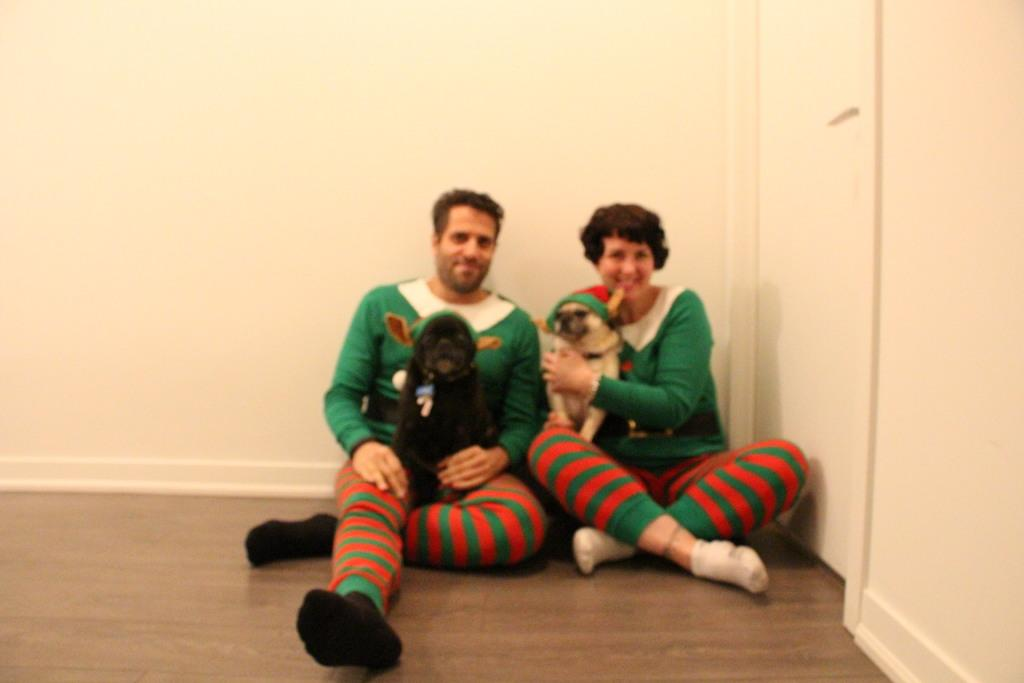How many people are in the image? There are two people in the image. What are the people doing in the image? The people are sitting on a wooden floor and holding dogs. What type of surface are the people sitting on? The people are sitting on a wooden floor. What can be seen in the background of the image? There are walls visible in the image. What type of record is being played in the image? There is no record present in the image; it features two people sitting on a wooden floor holding dogs. What is causing the people to quiver in the image? There is no indication in the image that the people are quivering, and no cause for such an action is visible. 